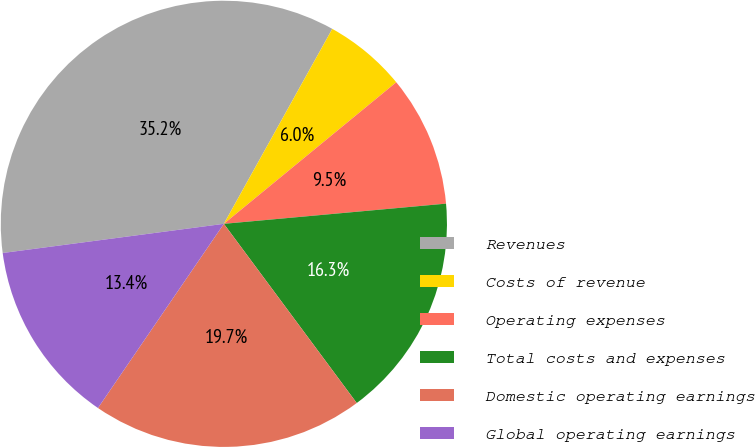Convert chart. <chart><loc_0><loc_0><loc_500><loc_500><pie_chart><fcel>Revenues<fcel>Costs of revenue<fcel>Operating expenses<fcel>Total costs and expenses<fcel>Domestic operating earnings<fcel>Global operating earnings<nl><fcel>35.17%<fcel>5.98%<fcel>9.5%<fcel>16.29%<fcel>19.7%<fcel>13.37%<nl></chart> 